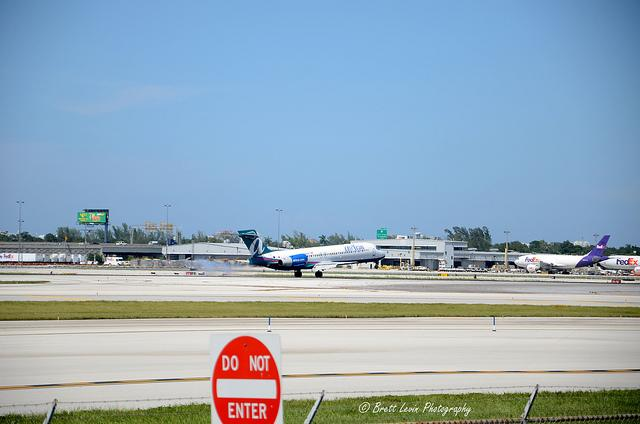What does the sign in front of the runways near the camera say?

Choices:
A) one way
B) stop
C) dead end
D) enter enter 